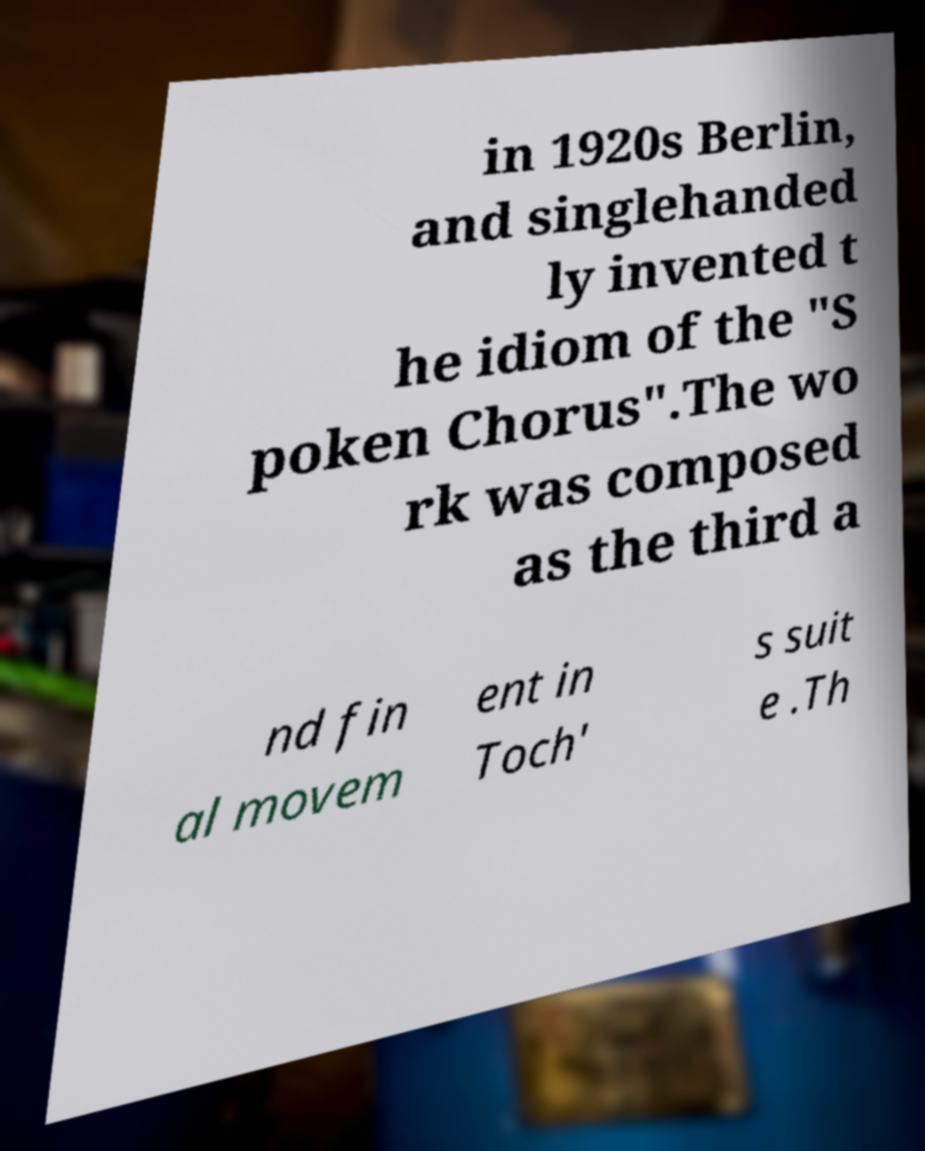For documentation purposes, I need the text within this image transcribed. Could you provide that? in 1920s Berlin, and singlehanded ly invented t he idiom of the "S poken Chorus".The wo rk was composed as the third a nd fin al movem ent in Toch' s suit e .Th 